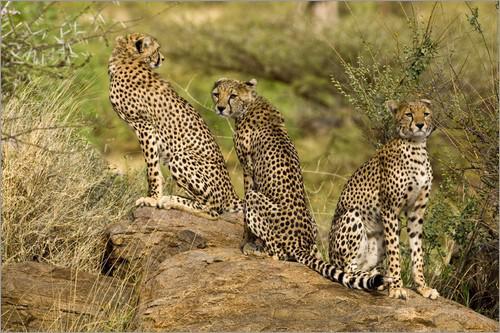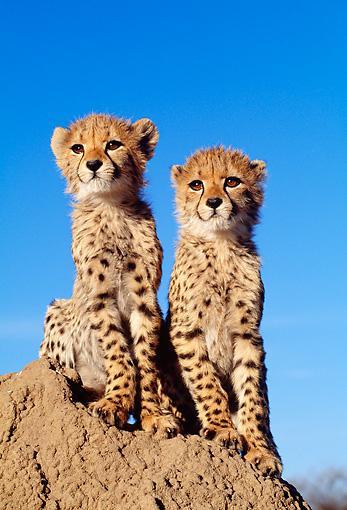The first image is the image on the left, the second image is the image on the right. For the images shown, is this caption "There is exactly one cheetah sitting on a rock." true? Answer yes or no. No. The first image is the image on the left, the second image is the image on the right. Evaluate the accuracy of this statement regarding the images: "Each image shows a single sitting adult cheetah with its head upright and its face turned mostly forward.". Is it true? Answer yes or no. No. 